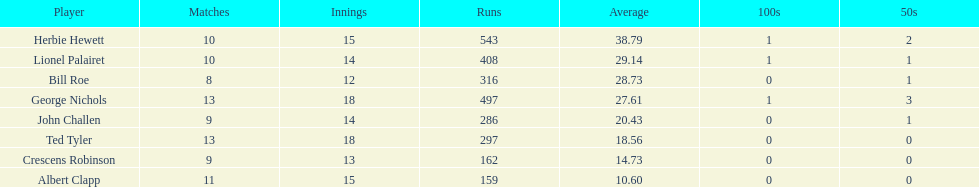Who had the minimum run count among the players? Albert Clapp. 